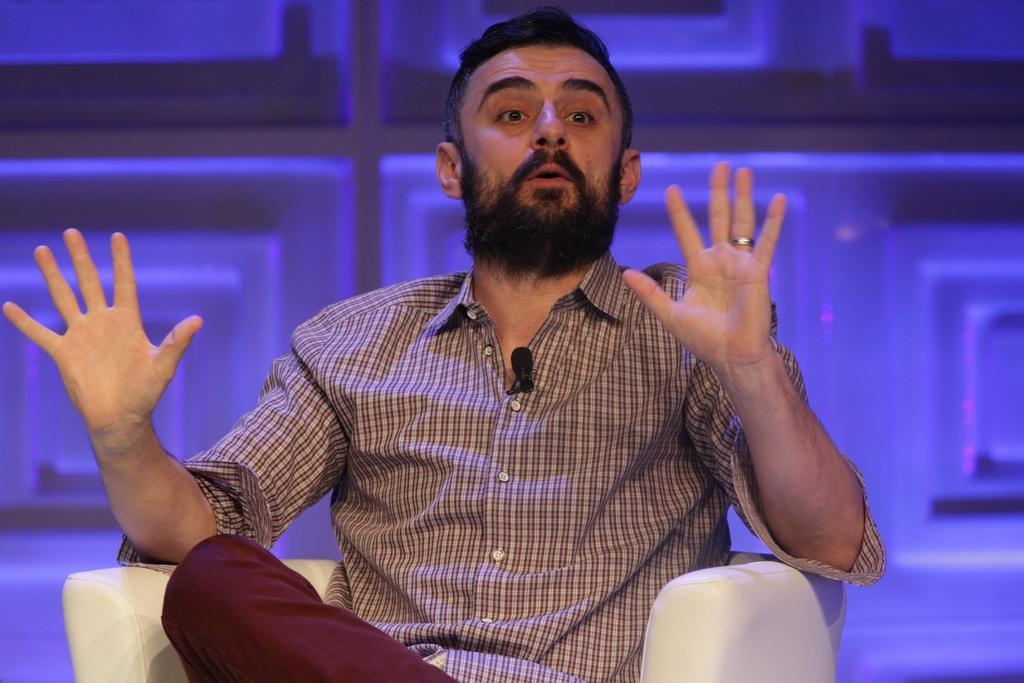Describe this image in one or two sentences. In the center of this picture there is a man with a beard and a mustache, wearing a shirt and sitting on a white color couch. In the background there are some objects. 